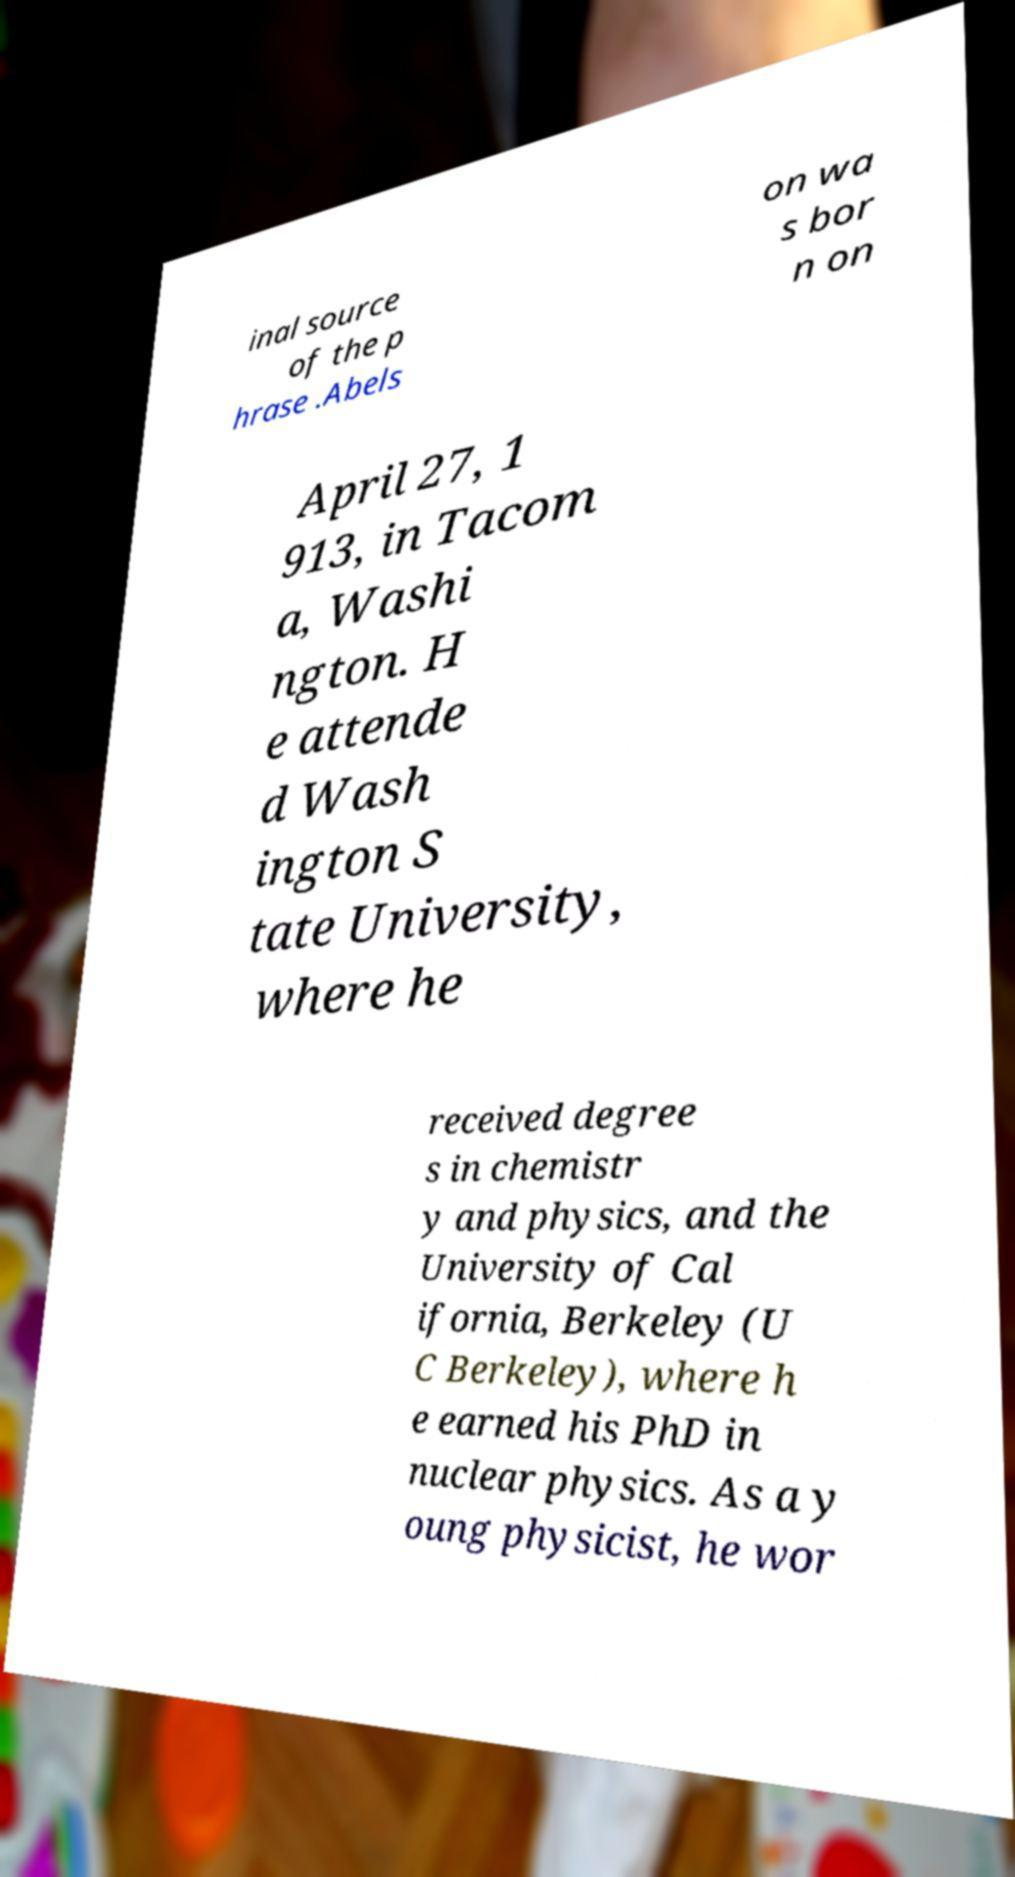I need the written content from this picture converted into text. Can you do that? inal source of the p hrase .Abels on wa s bor n on April 27, 1 913, in Tacom a, Washi ngton. H e attende d Wash ington S tate University, where he received degree s in chemistr y and physics, and the University of Cal ifornia, Berkeley (U C Berkeley), where h e earned his PhD in nuclear physics. As a y oung physicist, he wor 